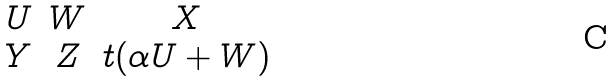Convert formula to latex. <formula><loc_0><loc_0><loc_500><loc_500>\begin{matrix} U & W & X \\ Y & Z & t ( \alpha U + W ) \end{matrix}</formula> 